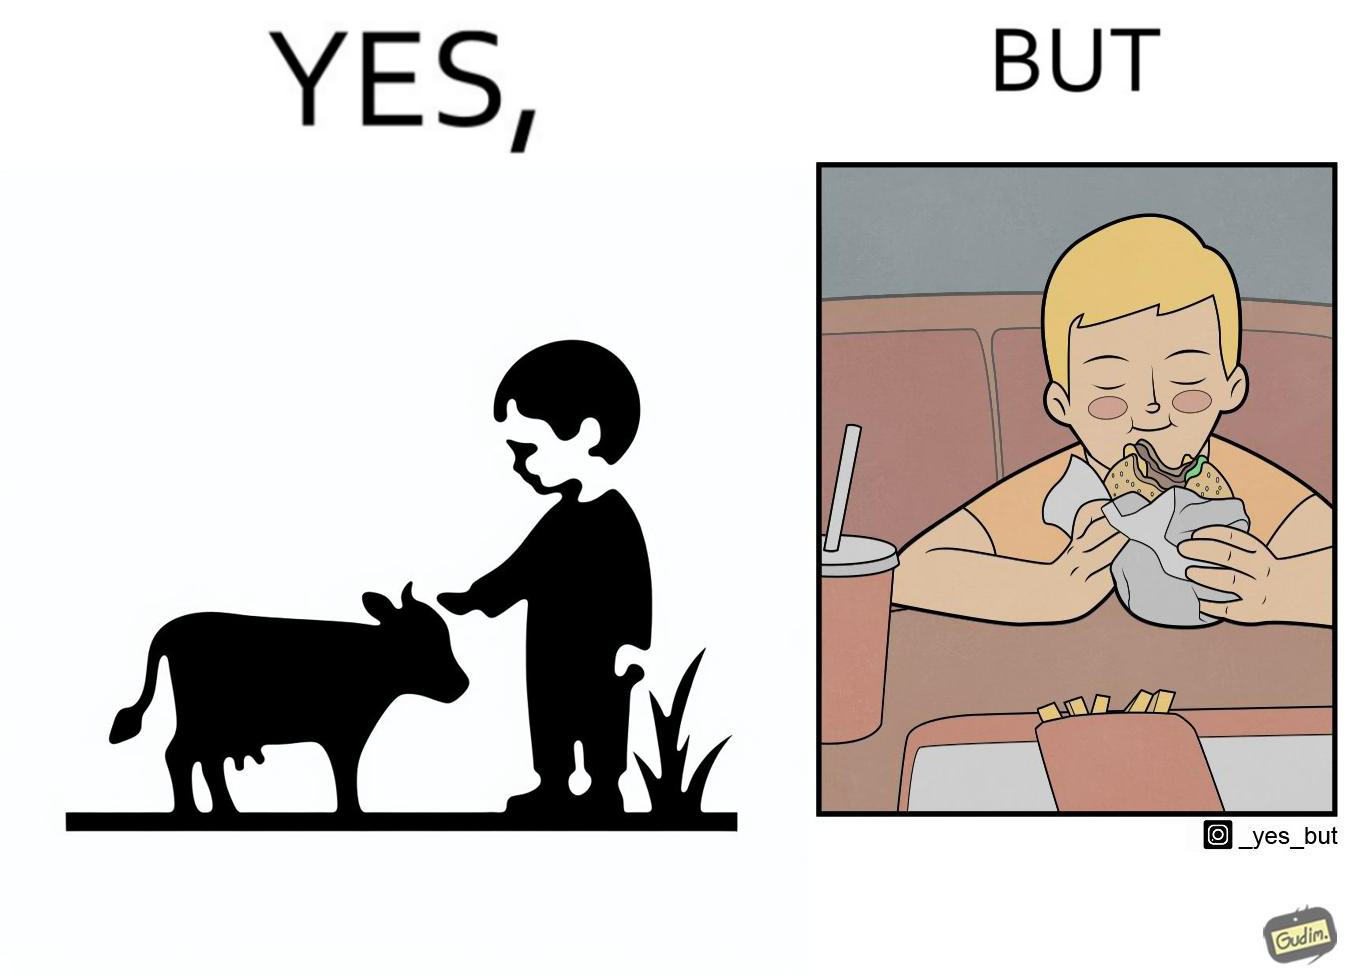Provide a description of this image. The irony is that the boy is petting the cow to show that he cares about the animal, but then he also eats hamburgers made from the same cows 